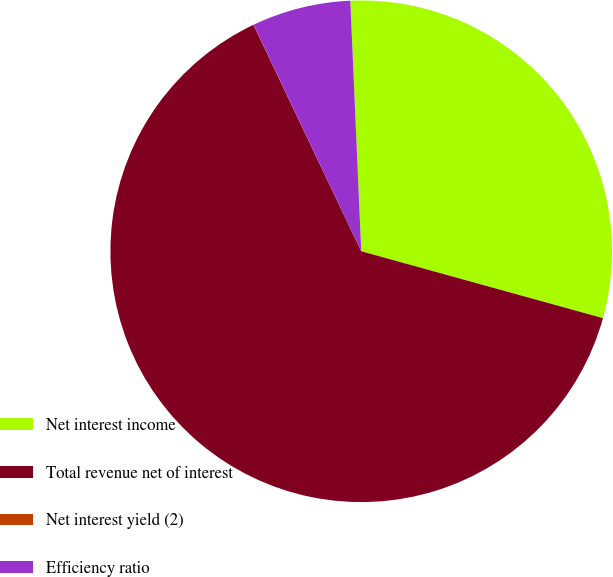Convert chart to OTSL. <chart><loc_0><loc_0><loc_500><loc_500><pie_chart><fcel>Net interest income<fcel>Total revenue net of interest<fcel>Net interest yield (2)<fcel>Efficiency ratio<nl><fcel>29.99%<fcel>63.63%<fcel>0.01%<fcel>6.37%<nl></chart> 